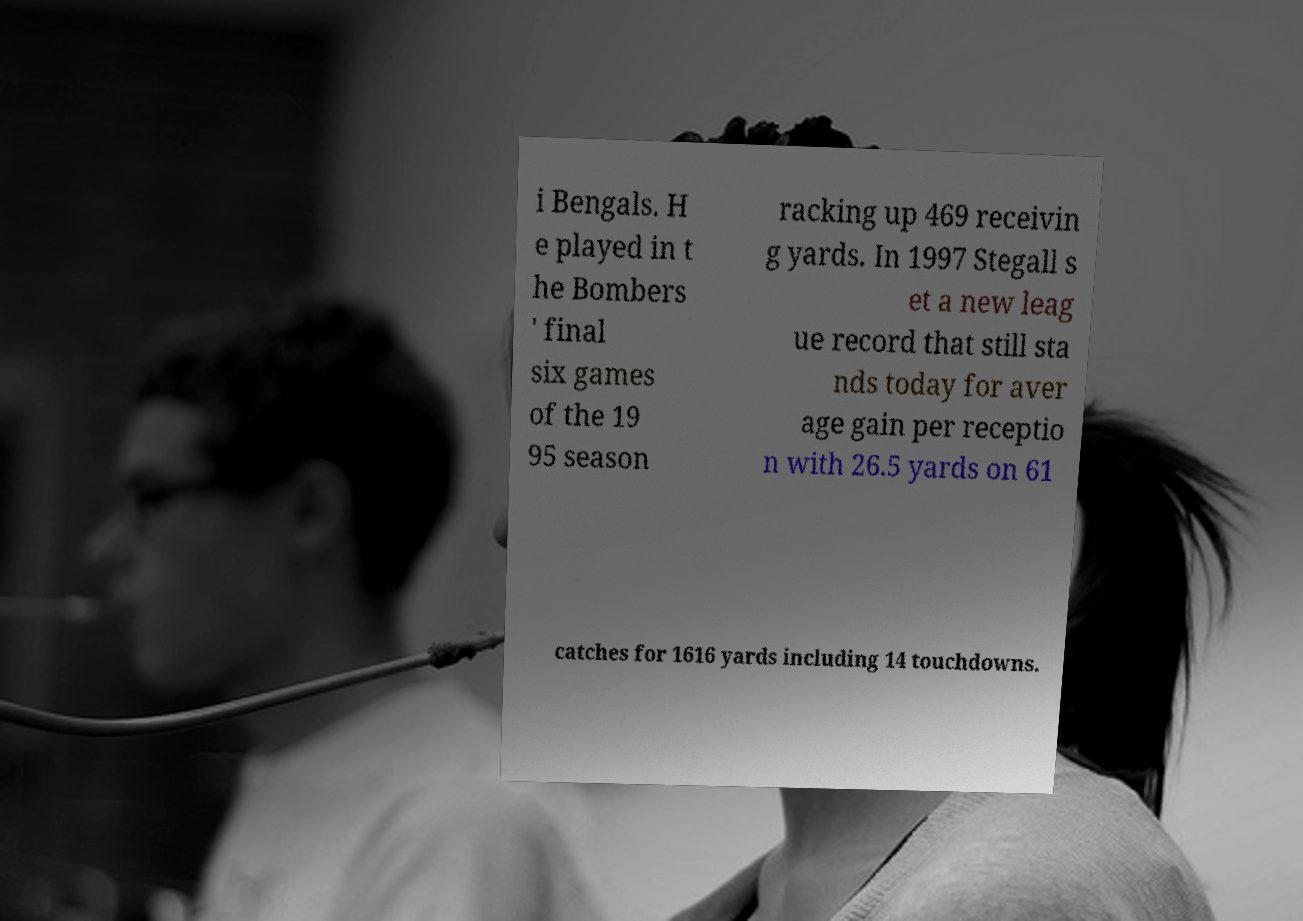Can you accurately transcribe the text from the provided image for me? i Bengals. H e played in t he Bombers ' final six games of the 19 95 season racking up 469 receivin g yards. In 1997 Stegall s et a new leag ue record that still sta nds today for aver age gain per receptio n with 26.5 yards on 61 catches for 1616 yards including 14 touchdowns. 